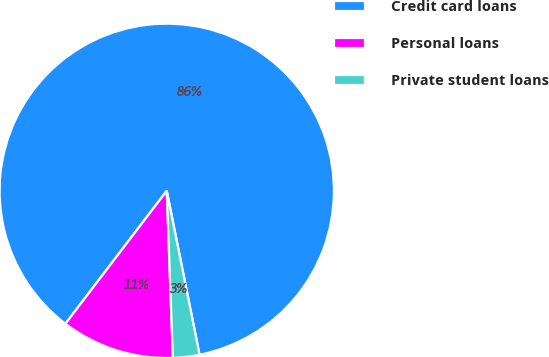Convert chart. <chart><loc_0><loc_0><loc_500><loc_500><pie_chart><fcel>Credit card loans<fcel>Personal loans<fcel>Private student loans<nl><fcel>86.49%<fcel>10.95%<fcel>2.56%<nl></chart> 